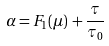Convert formula to latex. <formula><loc_0><loc_0><loc_500><loc_500>\alpha = { F } _ { 1 } ( \mu ) \, + \frac { \tau } { \tau _ { 0 } }</formula> 